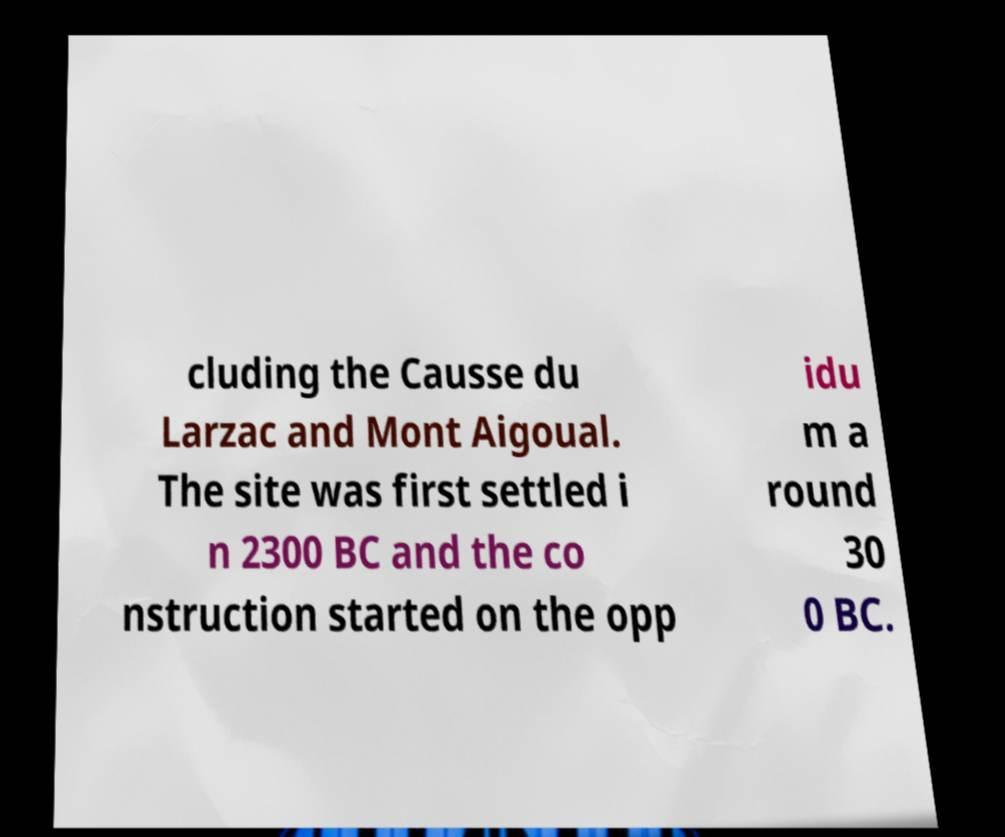There's text embedded in this image that I need extracted. Can you transcribe it verbatim? cluding the Causse du Larzac and Mont Aigoual. The site was first settled i n 2300 BC and the co nstruction started on the opp idu m a round 30 0 BC. 